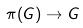<formula> <loc_0><loc_0><loc_500><loc_500>\pi ( G ) \rightarrow G</formula> 